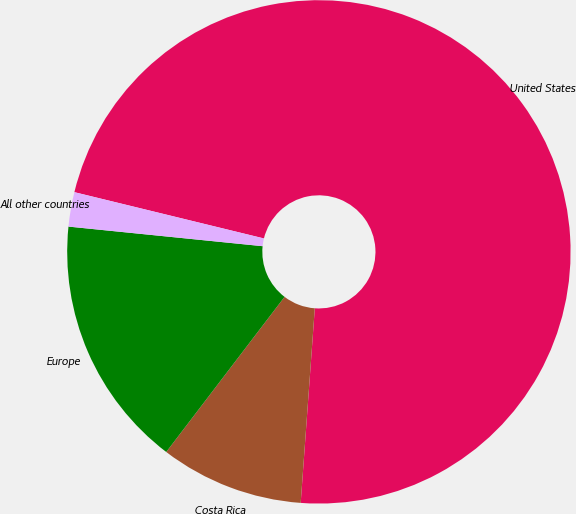Convert chart to OTSL. <chart><loc_0><loc_0><loc_500><loc_500><pie_chart><fcel>United States<fcel>Costa Rica<fcel>Europe<fcel>All other countries<nl><fcel>72.34%<fcel>9.22%<fcel>16.23%<fcel>2.21%<nl></chart> 